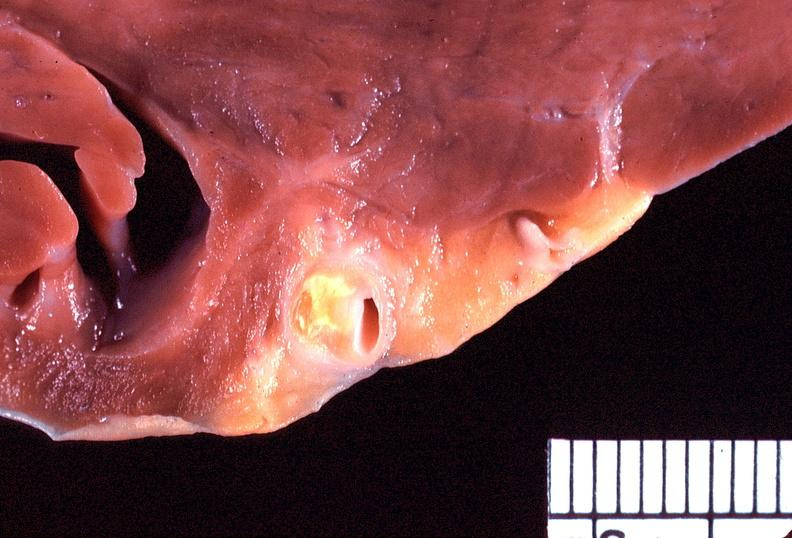where is this?
Answer the question using a single word or phrase. Heart 